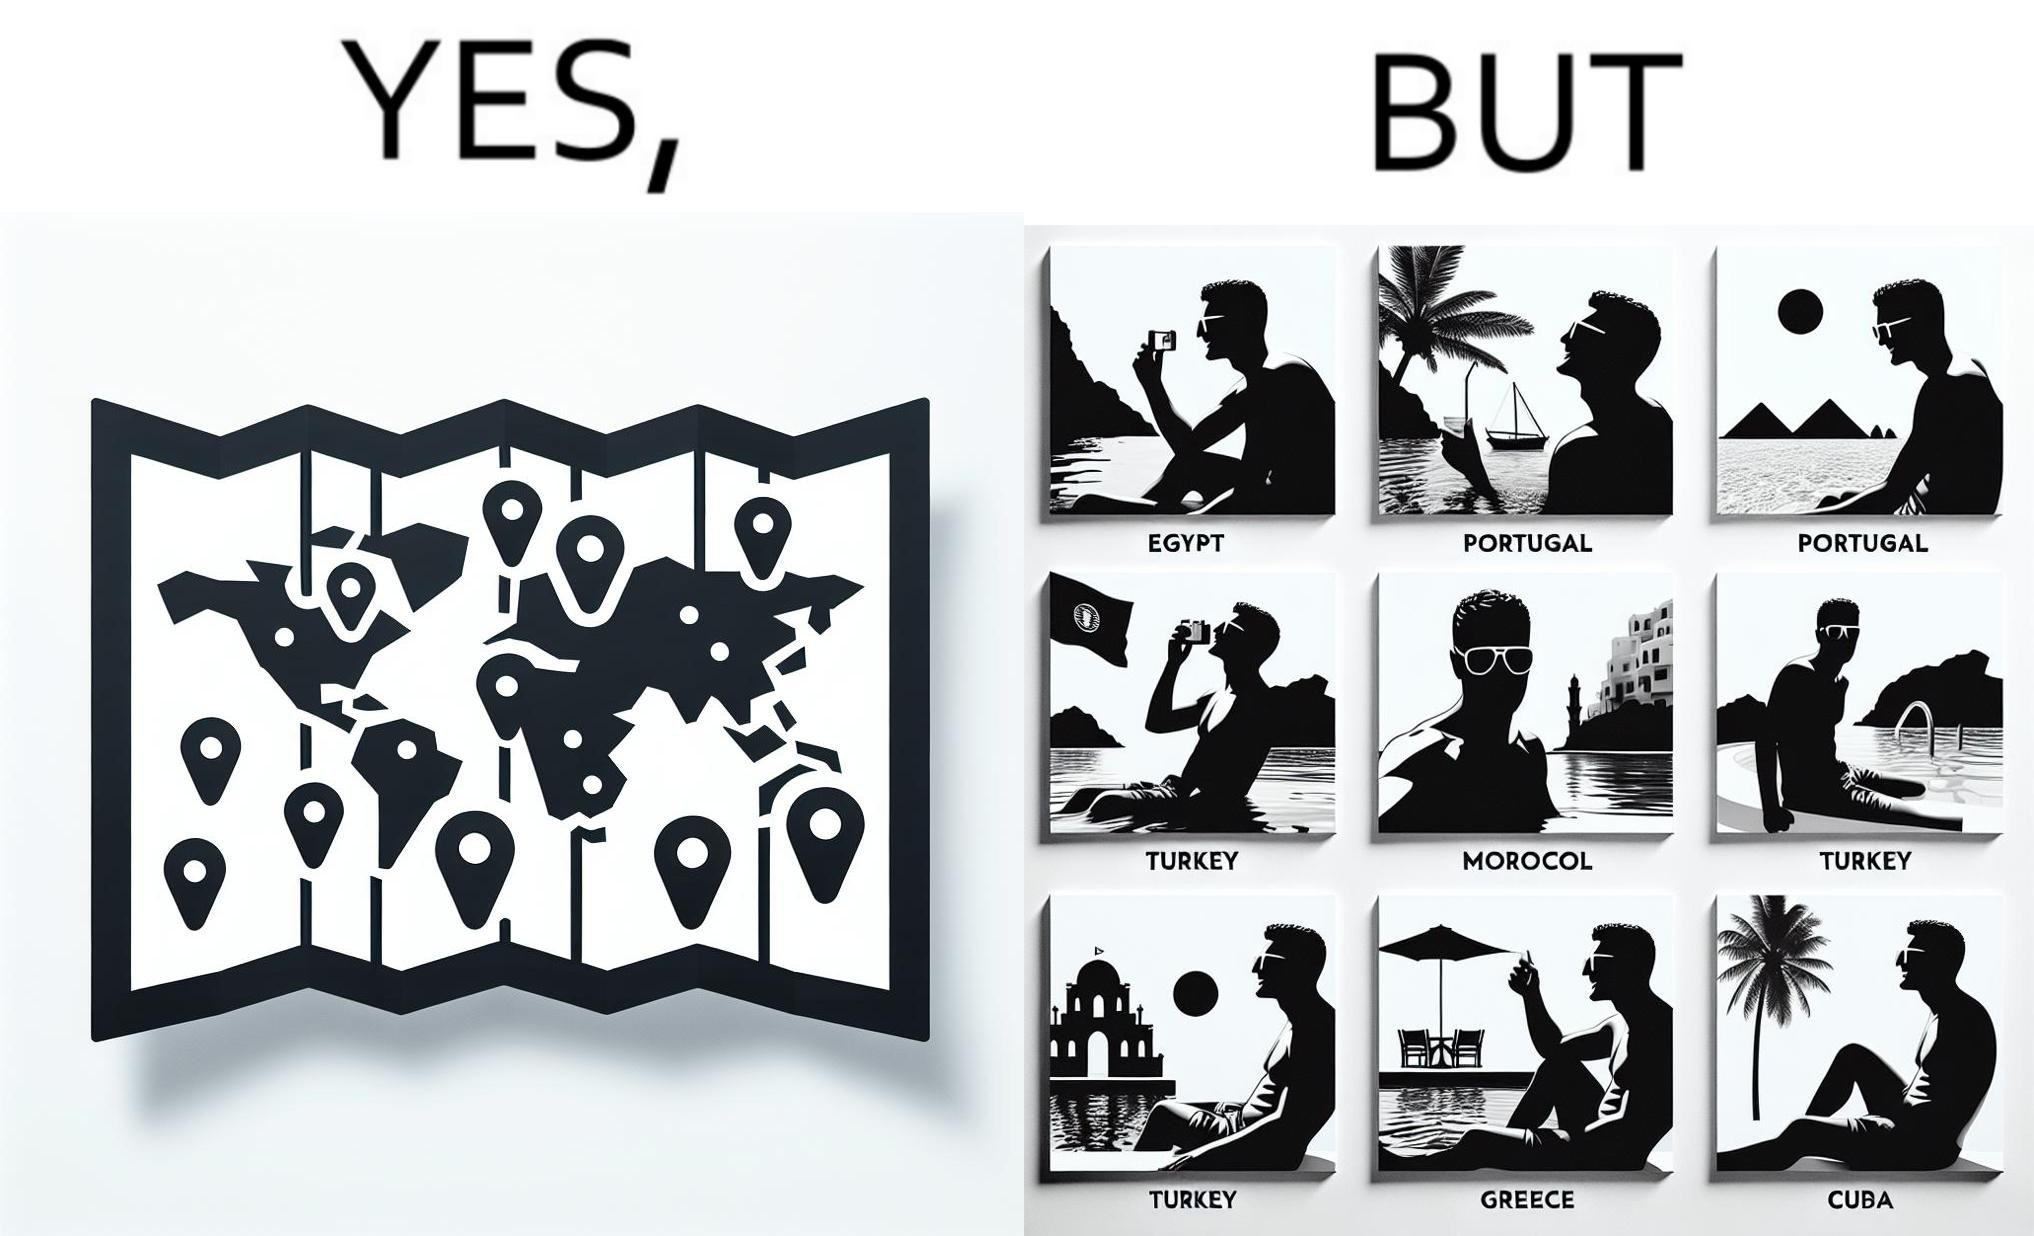Explain the humor or irony in this image. The image is satirical because while the man has visited all the place marked on the map, he only seems to have swam in pools in all these differnt countries and has not actually seen these places. 